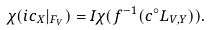Convert formula to latex. <formula><loc_0><loc_0><loc_500><loc_500>\chi ( i c _ { X } | _ { F _ { V } } ) = I \chi ( f ^ { - 1 } ( c ^ { \circ } L _ { V , Y } ) ) .</formula> 